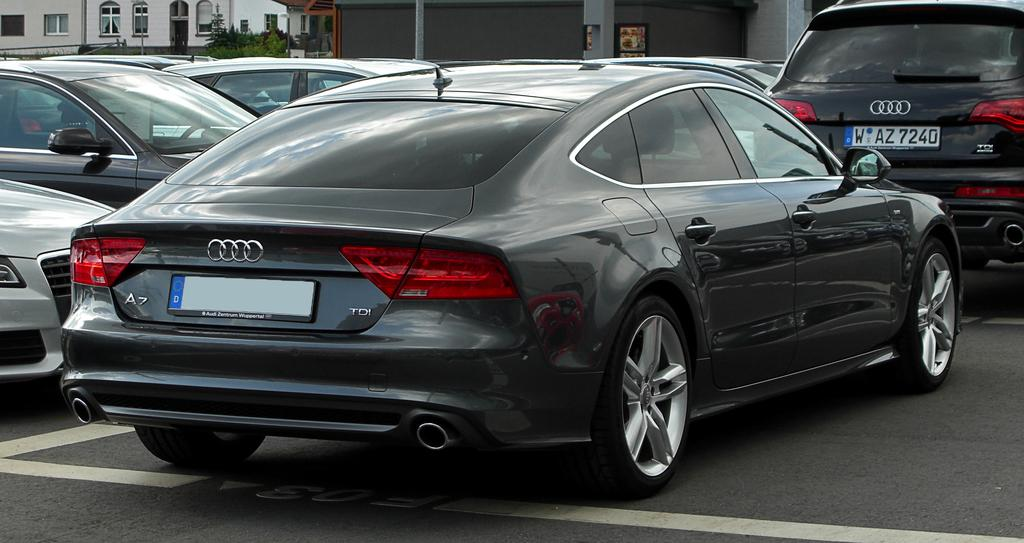<image>
Summarize the visual content of the image. A black Audi sedan is behind an Audi SUV, with the license plate WAZ7240. 